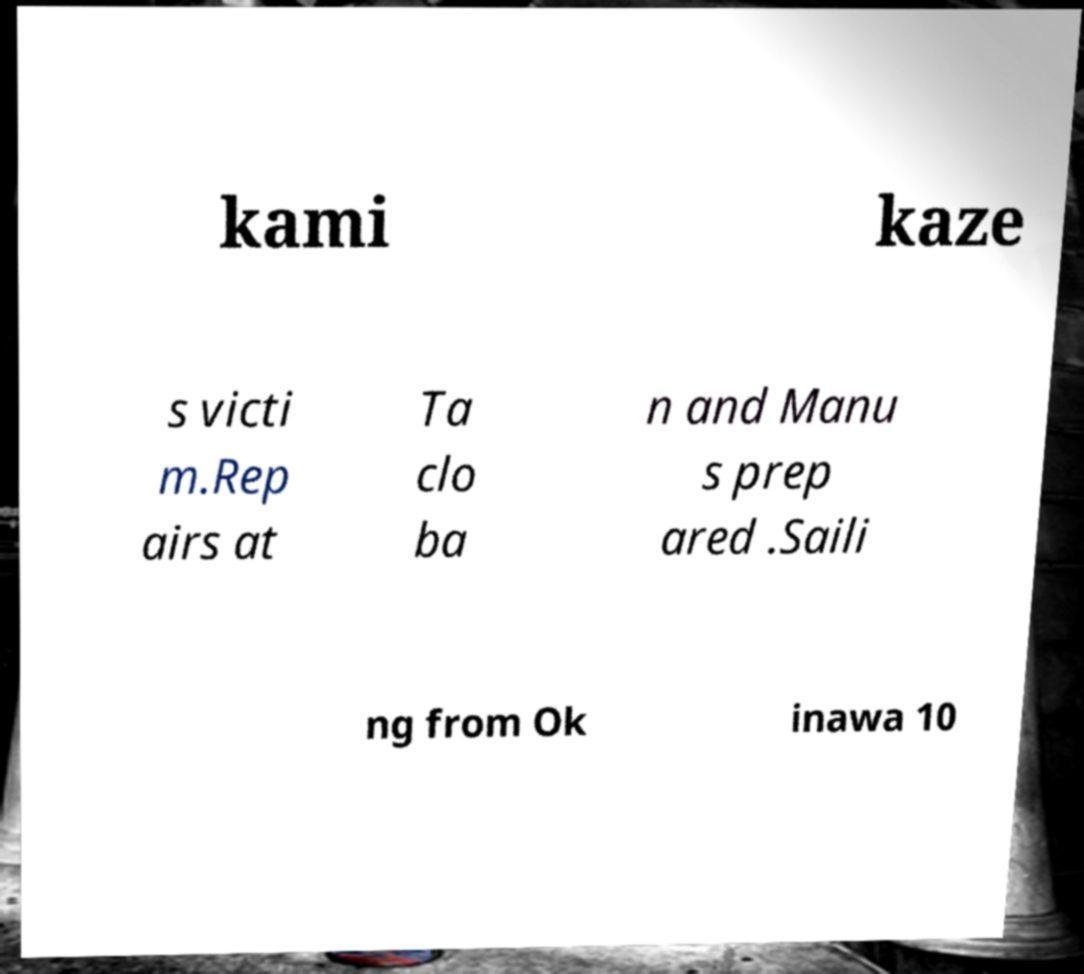Please identify and transcribe the text found in this image. kami kaze s victi m.Rep airs at Ta clo ba n and Manu s prep ared .Saili ng from Ok inawa 10 